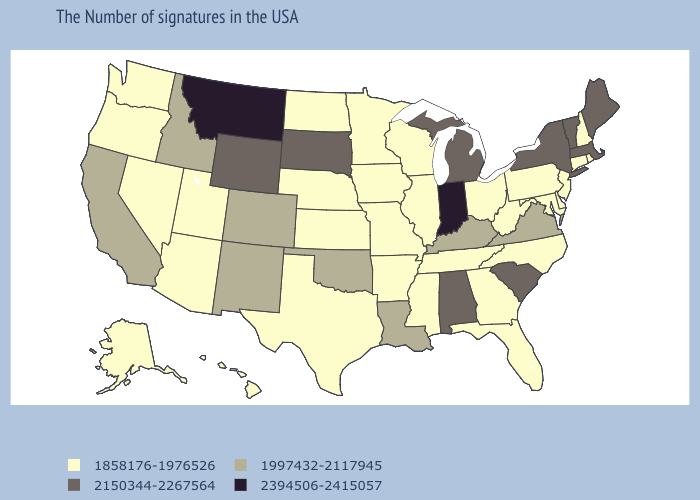Does New York have the lowest value in the Northeast?
Give a very brief answer. No. What is the value of Montana?
Be succinct. 2394506-2415057. Name the states that have a value in the range 1997432-2117945?
Answer briefly. Virginia, Kentucky, Louisiana, Oklahoma, Colorado, New Mexico, Idaho, California. What is the value of Utah?
Write a very short answer. 1858176-1976526. How many symbols are there in the legend?
Concise answer only. 4. Which states have the lowest value in the MidWest?
Short answer required. Ohio, Wisconsin, Illinois, Missouri, Minnesota, Iowa, Kansas, Nebraska, North Dakota. How many symbols are there in the legend?
Answer briefly. 4. Name the states that have a value in the range 2394506-2415057?
Short answer required. Indiana, Montana. What is the lowest value in states that border Nebraska?
Be succinct. 1858176-1976526. What is the value of Texas?
Keep it brief. 1858176-1976526. Does Montana have the highest value in the West?
Keep it brief. Yes. Does Wyoming have the same value as Massachusetts?
Be succinct. Yes. What is the value of Illinois?
Quick response, please. 1858176-1976526. Does Colorado have the same value as Idaho?
Keep it brief. Yes. What is the value of Michigan?
Short answer required. 2150344-2267564. 